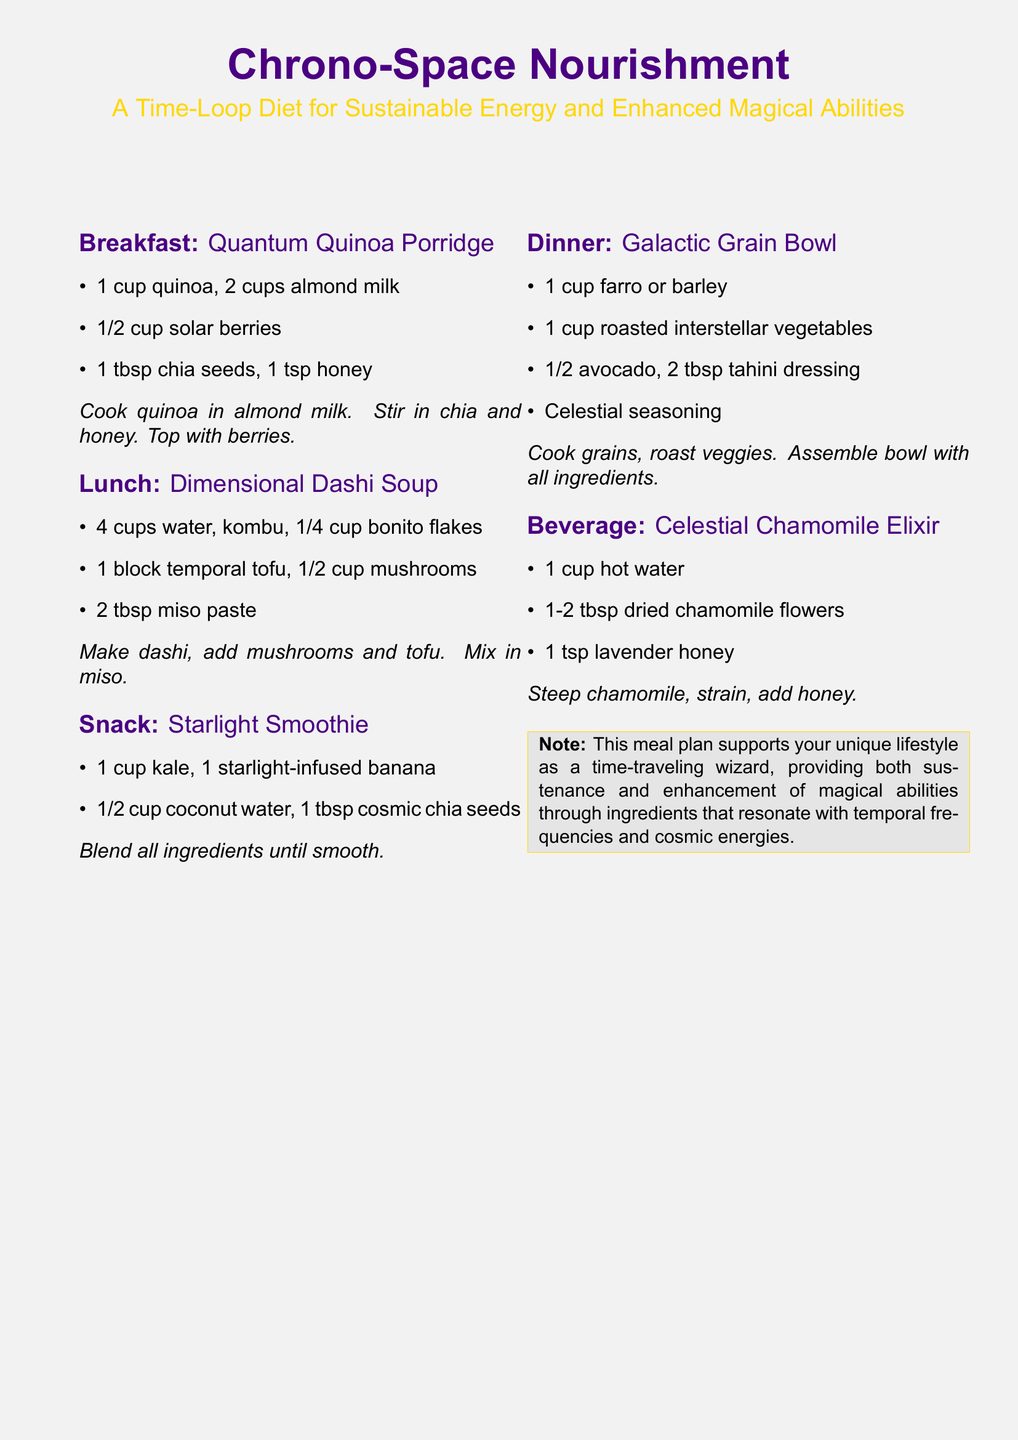What is the title of the meal plan? The title is presented in a large font at the beginning of the document.
Answer: Chrono-Space Nourishment What is the first ingredient in the breakfast? The first ingredient listed under breakfast is noted in the itemized list.
Answer: 1 cup quinoa How many cups of water are used in the Dimensional Dashi Soup? The amount of water is provided in the list of ingredients for lunch.
Answer: 4 cups What is the main vegetable included in the Starlight Smoothie? The primary vegetable is mentioned in the recipe for the snack.
Answer: kale What is the purpose of the meal plan? The purpose is described in the introductory text at the beginning of the document.
Answer: sustain energy and enhance magical abilities How many tablespoons of tahini dressing are used in the Galactic Grain Bowl? The quantity of tahini dressing is included in the ingredient list for dinner.
Answer: 2 tbsp Which beverage is mentioned in the meal plan? The beverage is listed in its own section towards the end of the document.
Answer: Celestial Chamomile Elixir What is added to the Celestial Chamomile Elixir for sweetness? The sweetening agent is specified in the recipe for the beverage.
Answer: 1 tsp lavender honey 